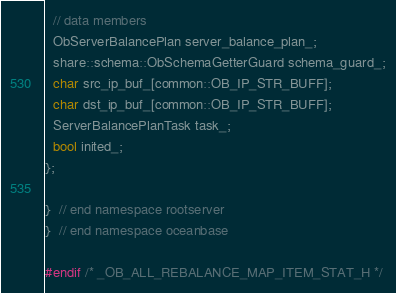Convert code to text. <code><loc_0><loc_0><loc_500><loc_500><_C_>  // data members
  ObServerBalancePlan server_balance_plan_;
  share::schema::ObSchemaGetterGuard schema_guard_;
  char src_ip_buf_[common::OB_IP_STR_BUFF];
  char dst_ip_buf_[common::OB_IP_STR_BUFF];
  ServerBalancePlanTask task_;
  bool inited_;
};

}  // end namespace rootserver
}  // end namespace oceanbase

#endif /* _OB_ALL_REBALANCE_MAP_ITEM_STAT_H */
</code> 